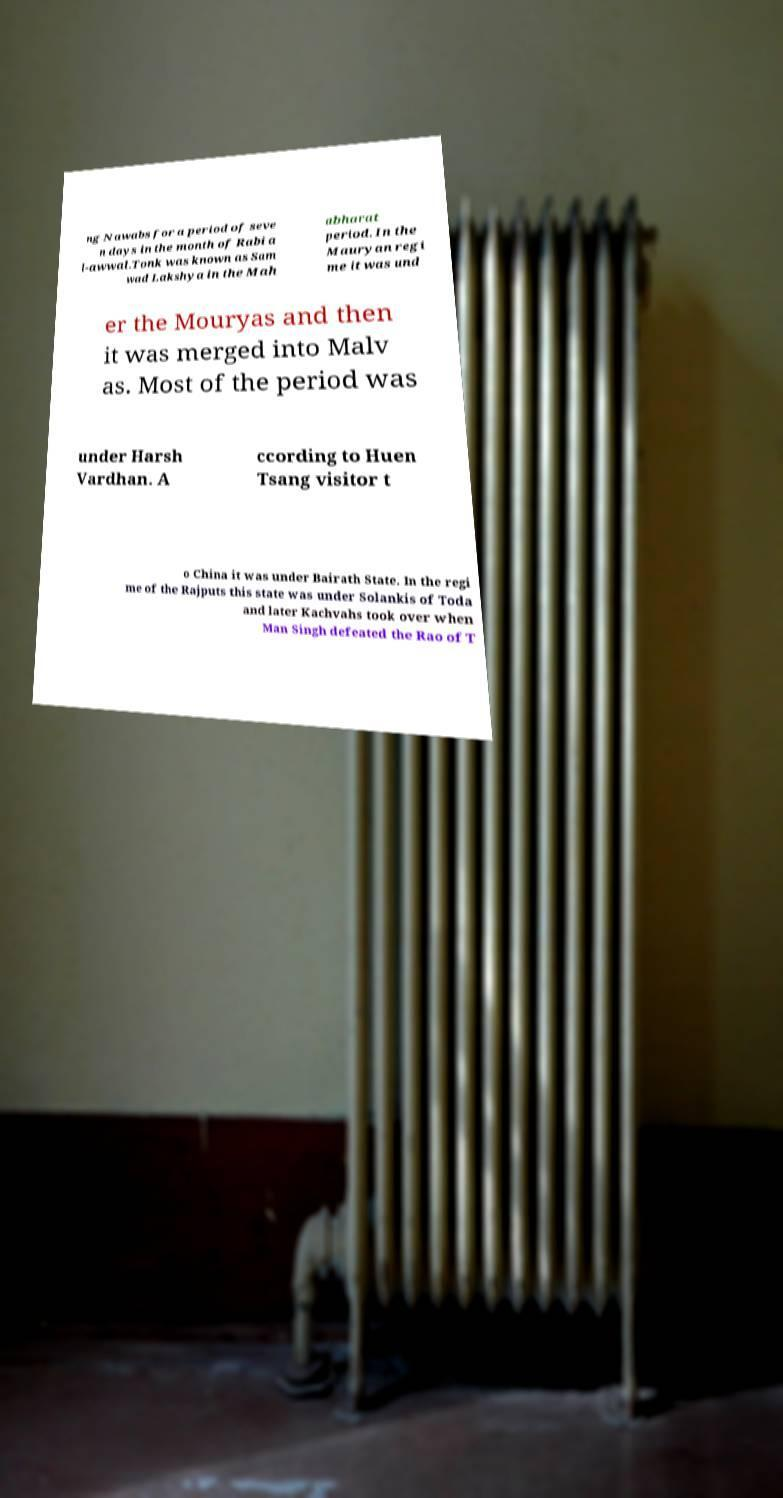There's text embedded in this image that I need extracted. Can you transcribe it verbatim? ng Nawabs for a period of seve n days in the month of Rabi a l-awwal.Tonk was known as Sam wad Lakshya in the Mah abharat period. In the Mauryan regi me it was und er the Mouryas and then it was merged into Malv as. Most of the period was under Harsh Vardhan. A ccording to Huen Tsang visitor t o China it was under Bairath State. In the regi me of the Rajputs this state was under Solankis of Toda and later Kachvahs took over when Man Singh defeated the Rao of T 